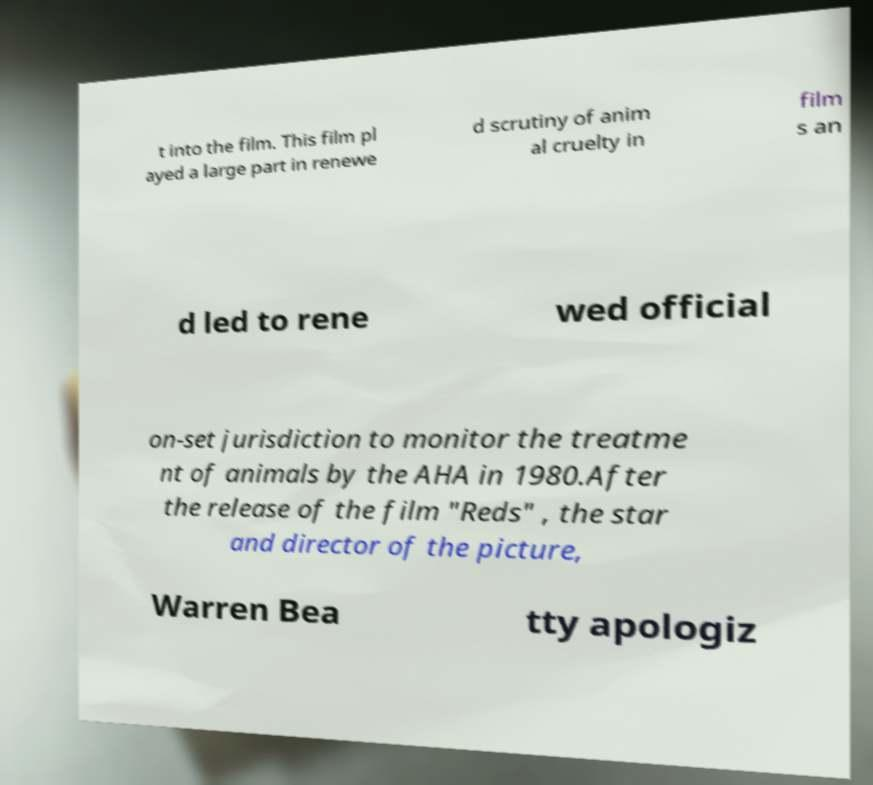Please identify and transcribe the text found in this image. t into the film. This film pl ayed a large part in renewe d scrutiny of anim al cruelty in film s an d led to rene wed official on-set jurisdiction to monitor the treatme nt of animals by the AHA in 1980.After the release of the film "Reds" , the star and director of the picture, Warren Bea tty apologiz 